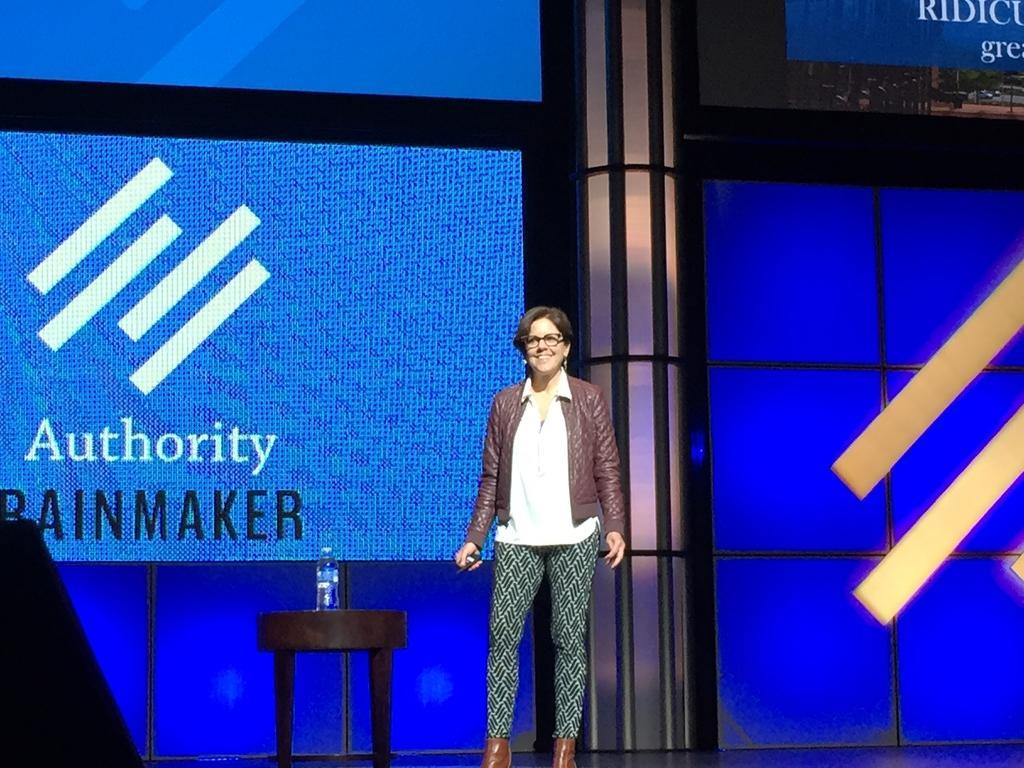Could you give a brief overview of what you see in this image? In this picture we can see a woman is standing and smiling in the middle, on the left side there is a table, we can see a bottle present on the table, it looks like a screen in the background, there is some text on the screen. 